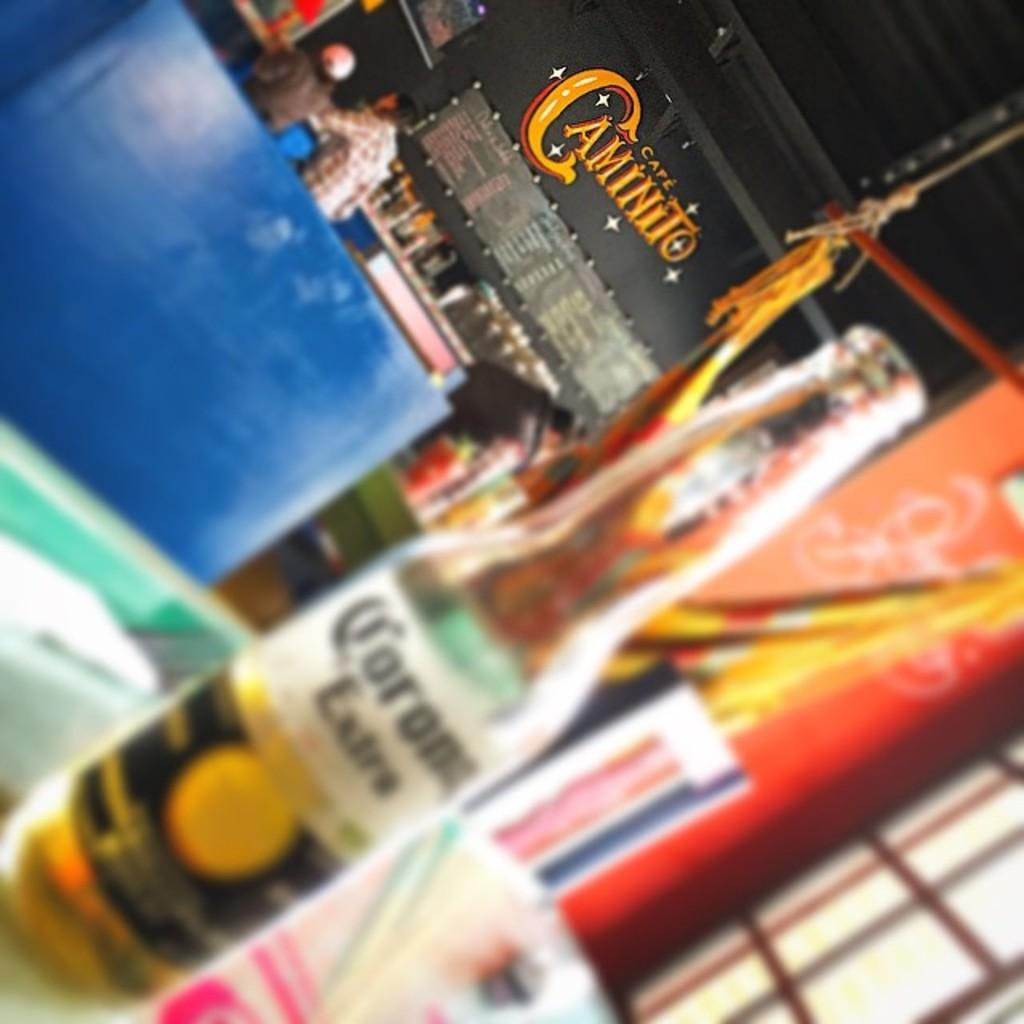<image>
Render a clear and concise summary of the photo. a bottle of corona extra on a table in cafe caminito 